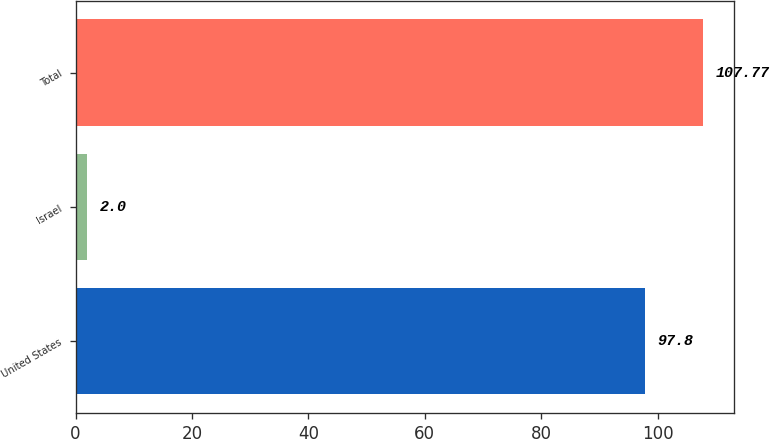<chart> <loc_0><loc_0><loc_500><loc_500><bar_chart><fcel>United States<fcel>Israel<fcel>Total<nl><fcel>97.8<fcel>2<fcel>107.77<nl></chart> 